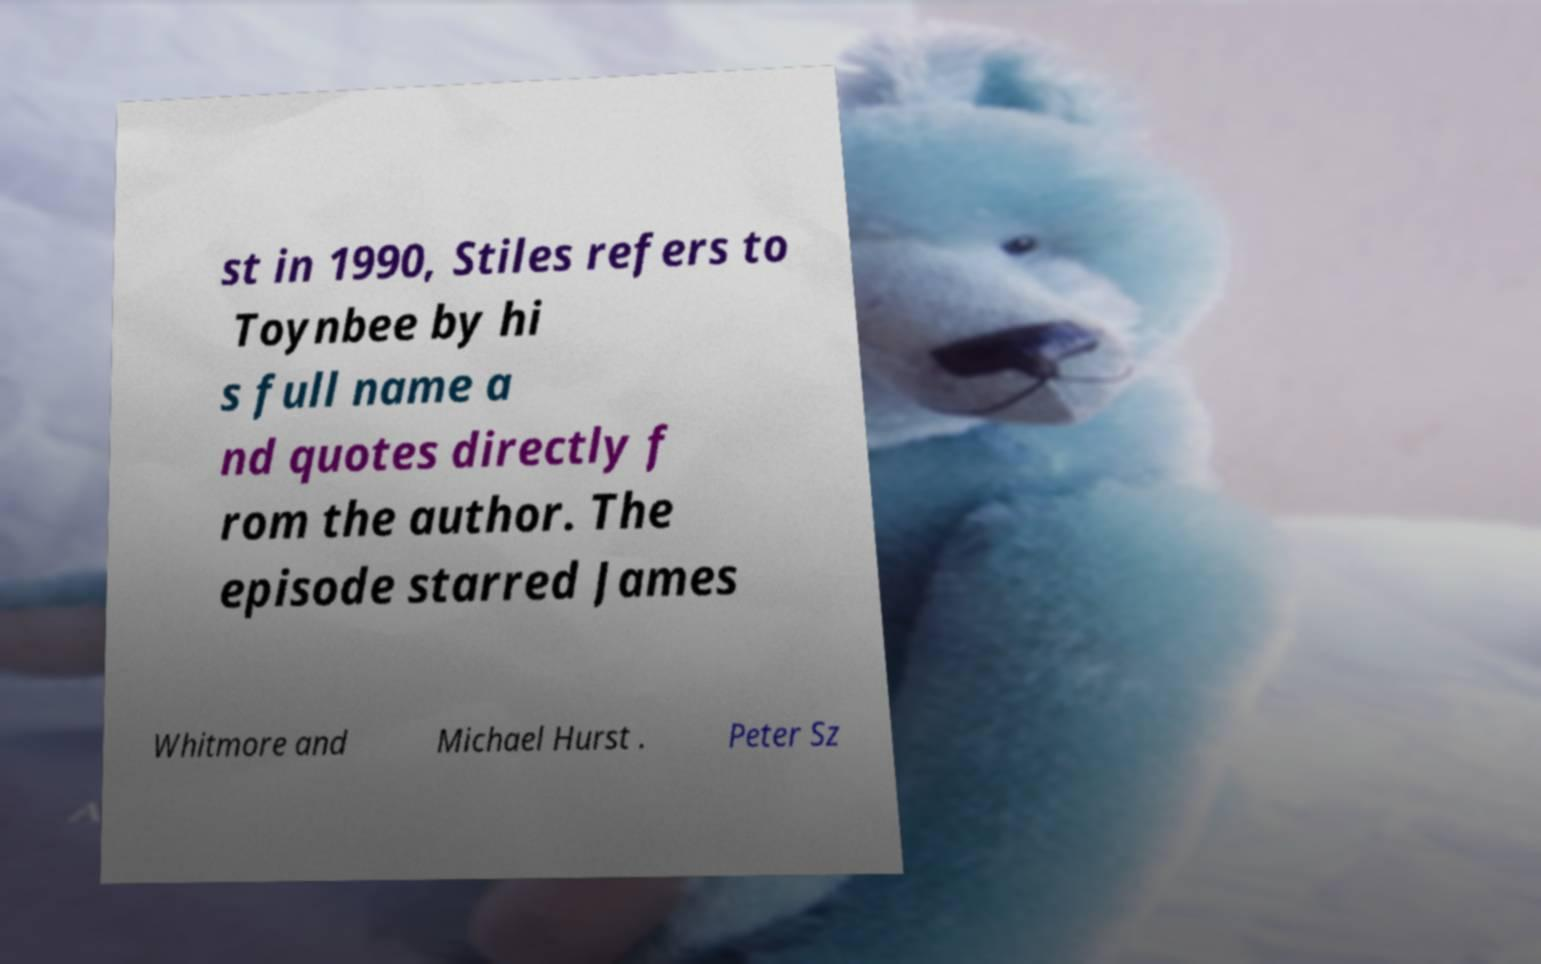Can you accurately transcribe the text from the provided image for me? st in 1990, Stiles refers to Toynbee by hi s full name a nd quotes directly f rom the author. The episode starred James Whitmore and Michael Hurst . Peter Sz 